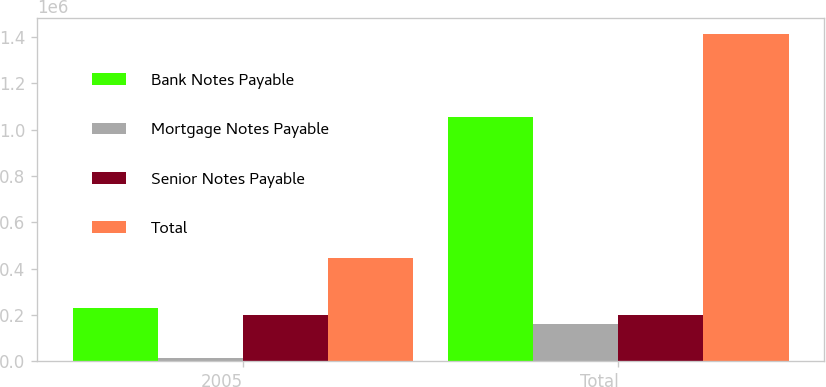Convert chart to OTSL. <chart><loc_0><loc_0><loc_500><loc_500><stacked_bar_chart><ecel><fcel>2005<fcel>Total<nl><fcel>Bank Notes Payable<fcel>231000<fcel>1.05442e+06<nl><fcel>Mortgage Notes Payable<fcel>16014<fcel>158808<nl><fcel>Senior Notes Payable<fcel>198000<fcel>198000<nl><fcel>Total<fcel>445014<fcel>1.41123e+06<nl></chart> 